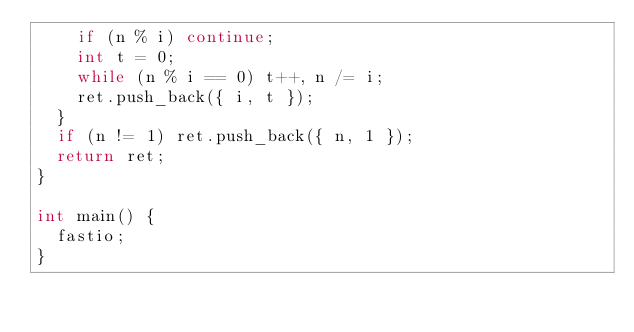<code> <loc_0><loc_0><loc_500><loc_500><_C++_>		if (n % i) continue;
		int t = 0;
		while (n % i == 0) t++, n /= i;
		ret.push_back({ i, t });
	}
	if (n != 1) ret.push_back({ n, 1 });
	return ret;
}

int main() {
	fastio;
}</code> 